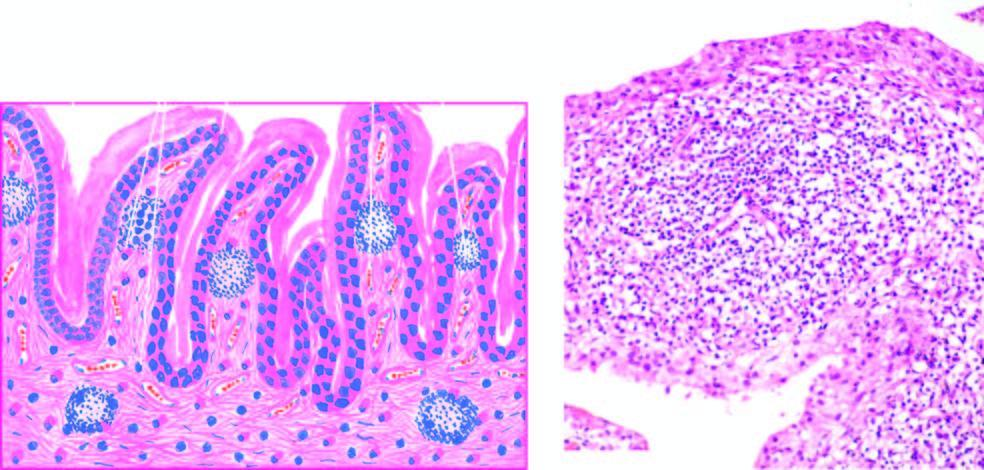re the characteristic histologic features villous hypertrophy of the synovium and marked mononuclear inflammatory cell infiltrate in synovial membrane with formation of lymphoid follicles at places?
Answer the question using a single word or phrase. Yes 